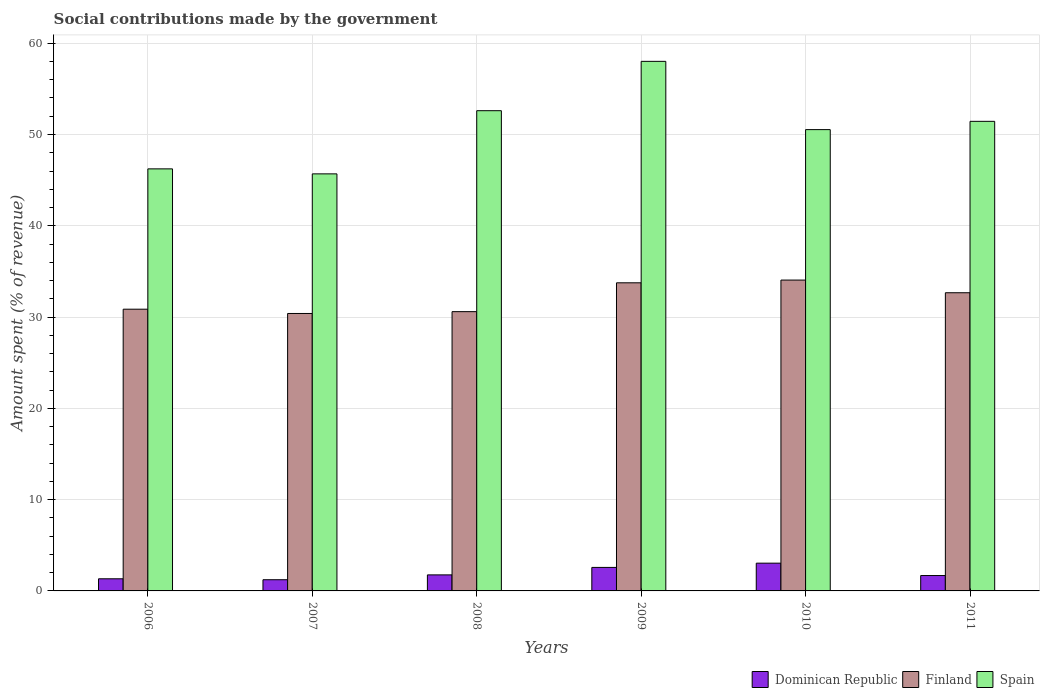Are the number of bars per tick equal to the number of legend labels?
Your response must be concise. Yes. Are the number of bars on each tick of the X-axis equal?
Offer a very short reply. Yes. How many bars are there on the 6th tick from the left?
Ensure brevity in your answer.  3. How many bars are there on the 2nd tick from the right?
Offer a very short reply. 3. In how many cases, is the number of bars for a given year not equal to the number of legend labels?
Keep it short and to the point. 0. What is the amount spent (in %) on social contributions in Finland in 2007?
Your response must be concise. 30.39. Across all years, what is the maximum amount spent (in %) on social contributions in Spain?
Your response must be concise. 58.01. Across all years, what is the minimum amount spent (in %) on social contributions in Finland?
Ensure brevity in your answer.  30.39. In which year was the amount spent (in %) on social contributions in Finland minimum?
Your answer should be compact. 2007. What is the total amount spent (in %) on social contributions in Finland in the graph?
Keep it short and to the point. 192.32. What is the difference between the amount spent (in %) on social contributions in Dominican Republic in 2006 and that in 2007?
Your answer should be compact. 0.1. What is the difference between the amount spent (in %) on social contributions in Finland in 2008 and the amount spent (in %) on social contributions in Spain in 2009?
Offer a terse response. -27.42. What is the average amount spent (in %) on social contributions in Finland per year?
Make the answer very short. 32.05. In the year 2008, what is the difference between the amount spent (in %) on social contributions in Spain and amount spent (in %) on social contributions in Finland?
Your response must be concise. 22.01. In how many years, is the amount spent (in %) on social contributions in Dominican Republic greater than 20 %?
Give a very brief answer. 0. What is the ratio of the amount spent (in %) on social contributions in Spain in 2007 to that in 2009?
Your response must be concise. 0.79. Is the amount spent (in %) on social contributions in Dominican Republic in 2006 less than that in 2009?
Make the answer very short. Yes. Is the difference between the amount spent (in %) on social contributions in Spain in 2006 and 2010 greater than the difference between the amount spent (in %) on social contributions in Finland in 2006 and 2010?
Offer a very short reply. No. What is the difference between the highest and the second highest amount spent (in %) on social contributions in Finland?
Offer a terse response. 0.3. What is the difference between the highest and the lowest amount spent (in %) on social contributions in Dominican Republic?
Keep it short and to the point. 1.81. In how many years, is the amount spent (in %) on social contributions in Finland greater than the average amount spent (in %) on social contributions in Finland taken over all years?
Your answer should be compact. 3. Is the sum of the amount spent (in %) on social contributions in Spain in 2010 and 2011 greater than the maximum amount spent (in %) on social contributions in Dominican Republic across all years?
Make the answer very short. Yes. What does the 1st bar from the left in 2006 represents?
Keep it short and to the point. Dominican Republic. What does the 3rd bar from the right in 2010 represents?
Give a very brief answer. Dominican Republic. Are all the bars in the graph horizontal?
Keep it short and to the point. No. How many years are there in the graph?
Provide a succinct answer. 6. What is the difference between two consecutive major ticks on the Y-axis?
Your answer should be very brief. 10. Does the graph contain grids?
Keep it short and to the point. Yes. Where does the legend appear in the graph?
Keep it short and to the point. Bottom right. How many legend labels are there?
Your response must be concise. 3. How are the legend labels stacked?
Your answer should be compact. Horizontal. What is the title of the graph?
Offer a very short reply. Social contributions made by the government. Does "Madagascar" appear as one of the legend labels in the graph?
Give a very brief answer. No. What is the label or title of the X-axis?
Ensure brevity in your answer.  Years. What is the label or title of the Y-axis?
Provide a succinct answer. Amount spent (% of revenue). What is the Amount spent (% of revenue) in Dominican Republic in 2006?
Provide a succinct answer. 1.33. What is the Amount spent (% of revenue) in Finland in 2006?
Make the answer very short. 30.86. What is the Amount spent (% of revenue) of Spain in 2006?
Offer a terse response. 46.23. What is the Amount spent (% of revenue) in Dominican Republic in 2007?
Your response must be concise. 1.23. What is the Amount spent (% of revenue) of Finland in 2007?
Keep it short and to the point. 30.39. What is the Amount spent (% of revenue) of Spain in 2007?
Your response must be concise. 45.69. What is the Amount spent (% of revenue) of Dominican Republic in 2008?
Keep it short and to the point. 1.76. What is the Amount spent (% of revenue) of Finland in 2008?
Give a very brief answer. 30.59. What is the Amount spent (% of revenue) of Spain in 2008?
Provide a short and direct response. 52.61. What is the Amount spent (% of revenue) in Dominican Republic in 2009?
Your answer should be compact. 2.58. What is the Amount spent (% of revenue) of Finland in 2009?
Your answer should be very brief. 33.75. What is the Amount spent (% of revenue) of Spain in 2009?
Offer a terse response. 58.01. What is the Amount spent (% of revenue) in Dominican Republic in 2010?
Your answer should be compact. 3.04. What is the Amount spent (% of revenue) in Finland in 2010?
Offer a very short reply. 34.05. What is the Amount spent (% of revenue) of Spain in 2010?
Offer a terse response. 50.53. What is the Amount spent (% of revenue) in Dominican Republic in 2011?
Ensure brevity in your answer.  1.68. What is the Amount spent (% of revenue) in Finland in 2011?
Ensure brevity in your answer.  32.67. What is the Amount spent (% of revenue) in Spain in 2011?
Provide a succinct answer. 51.44. Across all years, what is the maximum Amount spent (% of revenue) in Dominican Republic?
Offer a very short reply. 3.04. Across all years, what is the maximum Amount spent (% of revenue) of Finland?
Your response must be concise. 34.05. Across all years, what is the maximum Amount spent (% of revenue) in Spain?
Provide a succinct answer. 58.01. Across all years, what is the minimum Amount spent (% of revenue) in Dominican Republic?
Keep it short and to the point. 1.23. Across all years, what is the minimum Amount spent (% of revenue) of Finland?
Provide a short and direct response. 30.39. Across all years, what is the minimum Amount spent (% of revenue) of Spain?
Your answer should be very brief. 45.69. What is the total Amount spent (% of revenue) in Dominican Republic in the graph?
Offer a terse response. 11.61. What is the total Amount spent (% of revenue) of Finland in the graph?
Your answer should be compact. 192.32. What is the total Amount spent (% of revenue) in Spain in the graph?
Offer a terse response. 304.52. What is the difference between the Amount spent (% of revenue) of Dominican Republic in 2006 and that in 2007?
Your answer should be very brief. 0.1. What is the difference between the Amount spent (% of revenue) in Finland in 2006 and that in 2007?
Ensure brevity in your answer.  0.47. What is the difference between the Amount spent (% of revenue) in Spain in 2006 and that in 2007?
Provide a succinct answer. 0.55. What is the difference between the Amount spent (% of revenue) in Dominican Republic in 2006 and that in 2008?
Provide a succinct answer. -0.43. What is the difference between the Amount spent (% of revenue) in Finland in 2006 and that in 2008?
Make the answer very short. 0.27. What is the difference between the Amount spent (% of revenue) in Spain in 2006 and that in 2008?
Your answer should be very brief. -6.37. What is the difference between the Amount spent (% of revenue) of Dominican Republic in 2006 and that in 2009?
Your response must be concise. -1.25. What is the difference between the Amount spent (% of revenue) in Finland in 2006 and that in 2009?
Give a very brief answer. -2.89. What is the difference between the Amount spent (% of revenue) in Spain in 2006 and that in 2009?
Your answer should be compact. -11.78. What is the difference between the Amount spent (% of revenue) in Dominican Republic in 2006 and that in 2010?
Provide a succinct answer. -1.71. What is the difference between the Amount spent (% of revenue) in Finland in 2006 and that in 2010?
Ensure brevity in your answer.  -3.19. What is the difference between the Amount spent (% of revenue) in Spain in 2006 and that in 2010?
Make the answer very short. -4.3. What is the difference between the Amount spent (% of revenue) in Dominican Republic in 2006 and that in 2011?
Offer a terse response. -0.36. What is the difference between the Amount spent (% of revenue) of Finland in 2006 and that in 2011?
Your answer should be compact. -1.8. What is the difference between the Amount spent (% of revenue) in Spain in 2006 and that in 2011?
Offer a very short reply. -5.21. What is the difference between the Amount spent (% of revenue) of Dominican Republic in 2007 and that in 2008?
Offer a very short reply. -0.53. What is the difference between the Amount spent (% of revenue) in Finland in 2007 and that in 2008?
Ensure brevity in your answer.  -0.2. What is the difference between the Amount spent (% of revenue) in Spain in 2007 and that in 2008?
Offer a very short reply. -6.92. What is the difference between the Amount spent (% of revenue) of Dominican Republic in 2007 and that in 2009?
Keep it short and to the point. -1.35. What is the difference between the Amount spent (% of revenue) in Finland in 2007 and that in 2009?
Give a very brief answer. -3.36. What is the difference between the Amount spent (% of revenue) in Spain in 2007 and that in 2009?
Make the answer very short. -12.33. What is the difference between the Amount spent (% of revenue) of Dominican Republic in 2007 and that in 2010?
Your answer should be very brief. -1.81. What is the difference between the Amount spent (% of revenue) of Finland in 2007 and that in 2010?
Offer a very short reply. -3.66. What is the difference between the Amount spent (% of revenue) in Spain in 2007 and that in 2010?
Ensure brevity in your answer.  -4.85. What is the difference between the Amount spent (% of revenue) of Dominican Republic in 2007 and that in 2011?
Your answer should be compact. -0.46. What is the difference between the Amount spent (% of revenue) of Finland in 2007 and that in 2011?
Your answer should be very brief. -2.27. What is the difference between the Amount spent (% of revenue) of Spain in 2007 and that in 2011?
Make the answer very short. -5.75. What is the difference between the Amount spent (% of revenue) of Dominican Republic in 2008 and that in 2009?
Make the answer very short. -0.82. What is the difference between the Amount spent (% of revenue) in Finland in 2008 and that in 2009?
Provide a succinct answer. -3.16. What is the difference between the Amount spent (% of revenue) of Spain in 2008 and that in 2009?
Offer a terse response. -5.4. What is the difference between the Amount spent (% of revenue) of Dominican Republic in 2008 and that in 2010?
Provide a short and direct response. -1.28. What is the difference between the Amount spent (% of revenue) in Finland in 2008 and that in 2010?
Give a very brief answer. -3.46. What is the difference between the Amount spent (% of revenue) in Spain in 2008 and that in 2010?
Keep it short and to the point. 2.07. What is the difference between the Amount spent (% of revenue) of Dominican Republic in 2008 and that in 2011?
Keep it short and to the point. 0.07. What is the difference between the Amount spent (% of revenue) of Finland in 2008 and that in 2011?
Your answer should be very brief. -2.07. What is the difference between the Amount spent (% of revenue) of Spain in 2008 and that in 2011?
Keep it short and to the point. 1.17. What is the difference between the Amount spent (% of revenue) of Dominican Republic in 2009 and that in 2010?
Provide a succinct answer. -0.46. What is the difference between the Amount spent (% of revenue) in Finland in 2009 and that in 2010?
Provide a short and direct response. -0.3. What is the difference between the Amount spent (% of revenue) of Spain in 2009 and that in 2010?
Give a very brief answer. 7.48. What is the difference between the Amount spent (% of revenue) of Dominican Republic in 2009 and that in 2011?
Offer a terse response. 0.89. What is the difference between the Amount spent (% of revenue) of Finland in 2009 and that in 2011?
Provide a succinct answer. 1.09. What is the difference between the Amount spent (% of revenue) in Spain in 2009 and that in 2011?
Provide a succinct answer. 6.57. What is the difference between the Amount spent (% of revenue) of Dominican Republic in 2010 and that in 2011?
Provide a short and direct response. 1.36. What is the difference between the Amount spent (% of revenue) of Finland in 2010 and that in 2011?
Give a very brief answer. 1.39. What is the difference between the Amount spent (% of revenue) in Spain in 2010 and that in 2011?
Provide a succinct answer. -0.91. What is the difference between the Amount spent (% of revenue) of Dominican Republic in 2006 and the Amount spent (% of revenue) of Finland in 2007?
Give a very brief answer. -29.06. What is the difference between the Amount spent (% of revenue) of Dominican Republic in 2006 and the Amount spent (% of revenue) of Spain in 2007?
Your answer should be very brief. -44.36. What is the difference between the Amount spent (% of revenue) of Finland in 2006 and the Amount spent (% of revenue) of Spain in 2007?
Ensure brevity in your answer.  -14.83. What is the difference between the Amount spent (% of revenue) of Dominican Republic in 2006 and the Amount spent (% of revenue) of Finland in 2008?
Your answer should be compact. -29.26. What is the difference between the Amount spent (% of revenue) in Dominican Republic in 2006 and the Amount spent (% of revenue) in Spain in 2008?
Provide a short and direct response. -51.28. What is the difference between the Amount spent (% of revenue) in Finland in 2006 and the Amount spent (% of revenue) in Spain in 2008?
Keep it short and to the point. -21.75. What is the difference between the Amount spent (% of revenue) of Dominican Republic in 2006 and the Amount spent (% of revenue) of Finland in 2009?
Your answer should be very brief. -32.42. What is the difference between the Amount spent (% of revenue) of Dominican Republic in 2006 and the Amount spent (% of revenue) of Spain in 2009?
Give a very brief answer. -56.68. What is the difference between the Amount spent (% of revenue) in Finland in 2006 and the Amount spent (% of revenue) in Spain in 2009?
Your response must be concise. -27.15. What is the difference between the Amount spent (% of revenue) in Dominican Republic in 2006 and the Amount spent (% of revenue) in Finland in 2010?
Your answer should be compact. -32.72. What is the difference between the Amount spent (% of revenue) in Dominican Republic in 2006 and the Amount spent (% of revenue) in Spain in 2010?
Your answer should be very brief. -49.21. What is the difference between the Amount spent (% of revenue) of Finland in 2006 and the Amount spent (% of revenue) of Spain in 2010?
Keep it short and to the point. -19.67. What is the difference between the Amount spent (% of revenue) of Dominican Republic in 2006 and the Amount spent (% of revenue) of Finland in 2011?
Give a very brief answer. -31.34. What is the difference between the Amount spent (% of revenue) in Dominican Republic in 2006 and the Amount spent (% of revenue) in Spain in 2011?
Offer a very short reply. -50.11. What is the difference between the Amount spent (% of revenue) in Finland in 2006 and the Amount spent (% of revenue) in Spain in 2011?
Your answer should be compact. -20.58. What is the difference between the Amount spent (% of revenue) of Dominican Republic in 2007 and the Amount spent (% of revenue) of Finland in 2008?
Provide a short and direct response. -29.37. What is the difference between the Amount spent (% of revenue) of Dominican Republic in 2007 and the Amount spent (% of revenue) of Spain in 2008?
Your answer should be very brief. -51.38. What is the difference between the Amount spent (% of revenue) of Finland in 2007 and the Amount spent (% of revenue) of Spain in 2008?
Your answer should be compact. -22.21. What is the difference between the Amount spent (% of revenue) in Dominican Republic in 2007 and the Amount spent (% of revenue) in Finland in 2009?
Keep it short and to the point. -32.53. What is the difference between the Amount spent (% of revenue) in Dominican Republic in 2007 and the Amount spent (% of revenue) in Spain in 2009?
Make the answer very short. -56.79. What is the difference between the Amount spent (% of revenue) in Finland in 2007 and the Amount spent (% of revenue) in Spain in 2009?
Ensure brevity in your answer.  -27.62. What is the difference between the Amount spent (% of revenue) in Dominican Republic in 2007 and the Amount spent (% of revenue) in Finland in 2010?
Make the answer very short. -32.82. What is the difference between the Amount spent (% of revenue) in Dominican Republic in 2007 and the Amount spent (% of revenue) in Spain in 2010?
Offer a terse response. -49.31. What is the difference between the Amount spent (% of revenue) in Finland in 2007 and the Amount spent (% of revenue) in Spain in 2010?
Your answer should be very brief. -20.14. What is the difference between the Amount spent (% of revenue) of Dominican Republic in 2007 and the Amount spent (% of revenue) of Finland in 2011?
Your answer should be very brief. -31.44. What is the difference between the Amount spent (% of revenue) of Dominican Republic in 2007 and the Amount spent (% of revenue) of Spain in 2011?
Provide a succinct answer. -50.21. What is the difference between the Amount spent (% of revenue) in Finland in 2007 and the Amount spent (% of revenue) in Spain in 2011?
Your response must be concise. -21.05. What is the difference between the Amount spent (% of revenue) in Dominican Republic in 2008 and the Amount spent (% of revenue) in Finland in 2009?
Provide a succinct answer. -32. What is the difference between the Amount spent (% of revenue) of Dominican Republic in 2008 and the Amount spent (% of revenue) of Spain in 2009?
Offer a terse response. -56.25. What is the difference between the Amount spent (% of revenue) in Finland in 2008 and the Amount spent (% of revenue) in Spain in 2009?
Offer a terse response. -27.42. What is the difference between the Amount spent (% of revenue) of Dominican Republic in 2008 and the Amount spent (% of revenue) of Finland in 2010?
Your response must be concise. -32.29. What is the difference between the Amount spent (% of revenue) of Dominican Republic in 2008 and the Amount spent (% of revenue) of Spain in 2010?
Offer a very short reply. -48.78. What is the difference between the Amount spent (% of revenue) of Finland in 2008 and the Amount spent (% of revenue) of Spain in 2010?
Offer a very short reply. -19.94. What is the difference between the Amount spent (% of revenue) in Dominican Republic in 2008 and the Amount spent (% of revenue) in Finland in 2011?
Ensure brevity in your answer.  -30.91. What is the difference between the Amount spent (% of revenue) of Dominican Republic in 2008 and the Amount spent (% of revenue) of Spain in 2011?
Your answer should be very brief. -49.68. What is the difference between the Amount spent (% of revenue) of Finland in 2008 and the Amount spent (% of revenue) of Spain in 2011?
Your answer should be very brief. -20.85. What is the difference between the Amount spent (% of revenue) of Dominican Republic in 2009 and the Amount spent (% of revenue) of Finland in 2010?
Your answer should be compact. -31.48. What is the difference between the Amount spent (% of revenue) in Dominican Republic in 2009 and the Amount spent (% of revenue) in Spain in 2010?
Your answer should be very brief. -47.96. What is the difference between the Amount spent (% of revenue) in Finland in 2009 and the Amount spent (% of revenue) in Spain in 2010?
Your answer should be compact. -16.78. What is the difference between the Amount spent (% of revenue) in Dominican Republic in 2009 and the Amount spent (% of revenue) in Finland in 2011?
Your response must be concise. -30.09. What is the difference between the Amount spent (% of revenue) in Dominican Republic in 2009 and the Amount spent (% of revenue) in Spain in 2011?
Provide a succinct answer. -48.87. What is the difference between the Amount spent (% of revenue) in Finland in 2009 and the Amount spent (% of revenue) in Spain in 2011?
Your answer should be very brief. -17.69. What is the difference between the Amount spent (% of revenue) of Dominican Republic in 2010 and the Amount spent (% of revenue) of Finland in 2011?
Ensure brevity in your answer.  -29.63. What is the difference between the Amount spent (% of revenue) of Dominican Republic in 2010 and the Amount spent (% of revenue) of Spain in 2011?
Give a very brief answer. -48.4. What is the difference between the Amount spent (% of revenue) in Finland in 2010 and the Amount spent (% of revenue) in Spain in 2011?
Provide a short and direct response. -17.39. What is the average Amount spent (% of revenue) of Dominican Republic per year?
Ensure brevity in your answer.  1.94. What is the average Amount spent (% of revenue) in Finland per year?
Keep it short and to the point. 32.05. What is the average Amount spent (% of revenue) in Spain per year?
Provide a short and direct response. 50.75. In the year 2006, what is the difference between the Amount spent (% of revenue) in Dominican Republic and Amount spent (% of revenue) in Finland?
Keep it short and to the point. -29.53. In the year 2006, what is the difference between the Amount spent (% of revenue) in Dominican Republic and Amount spent (% of revenue) in Spain?
Offer a terse response. -44.91. In the year 2006, what is the difference between the Amount spent (% of revenue) of Finland and Amount spent (% of revenue) of Spain?
Provide a succinct answer. -15.37. In the year 2007, what is the difference between the Amount spent (% of revenue) in Dominican Republic and Amount spent (% of revenue) in Finland?
Give a very brief answer. -29.17. In the year 2007, what is the difference between the Amount spent (% of revenue) in Dominican Republic and Amount spent (% of revenue) in Spain?
Offer a terse response. -44.46. In the year 2007, what is the difference between the Amount spent (% of revenue) of Finland and Amount spent (% of revenue) of Spain?
Offer a terse response. -15.29. In the year 2008, what is the difference between the Amount spent (% of revenue) in Dominican Republic and Amount spent (% of revenue) in Finland?
Your response must be concise. -28.84. In the year 2008, what is the difference between the Amount spent (% of revenue) of Dominican Republic and Amount spent (% of revenue) of Spain?
Provide a succinct answer. -50.85. In the year 2008, what is the difference between the Amount spent (% of revenue) of Finland and Amount spent (% of revenue) of Spain?
Offer a terse response. -22.01. In the year 2009, what is the difference between the Amount spent (% of revenue) in Dominican Republic and Amount spent (% of revenue) in Finland?
Provide a succinct answer. -31.18. In the year 2009, what is the difference between the Amount spent (% of revenue) in Dominican Republic and Amount spent (% of revenue) in Spain?
Your answer should be very brief. -55.44. In the year 2009, what is the difference between the Amount spent (% of revenue) of Finland and Amount spent (% of revenue) of Spain?
Provide a succinct answer. -24.26. In the year 2010, what is the difference between the Amount spent (% of revenue) of Dominican Republic and Amount spent (% of revenue) of Finland?
Ensure brevity in your answer.  -31.01. In the year 2010, what is the difference between the Amount spent (% of revenue) in Dominican Republic and Amount spent (% of revenue) in Spain?
Offer a very short reply. -47.49. In the year 2010, what is the difference between the Amount spent (% of revenue) of Finland and Amount spent (% of revenue) of Spain?
Your answer should be very brief. -16.48. In the year 2011, what is the difference between the Amount spent (% of revenue) in Dominican Republic and Amount spent (% of revenue) in Finland?
Your response must be concise. -30.98. In the year 2011, what is the difference between the Amount spent (% of revenue) in Dominican Republic and Amount spent (% of revenue) in Spain?
Give a very brief answer. -49.76. In the year 2011, what is the difference between the Amount spent (% of revenue) in Finland and Amount spent (% of revenue) in Spain?
Provide a succinct answer. -18.78. What is the ratio of the Amount spent (% of revenue) of Dominican Republic in 2006 to that in 2007?
Ensure brevity in your answer.  1.08. What is the ratio of the Amount spent (% of revenue) of Finland in 2006 to that in 2007?
Make the answer very short. 1.02. What is the ratio of the Amount spent (% of revenue) in Dominican Republic in 2006 to that in 2008?
Offer a very short reply. 0.76. What is the ratio of the Amount spent (% of revenue) of Finland in 2006 to that in 2008?
Your answer should be compact. 1.01. What is the ratio of the Amount spent (% of revenue) in Spain in 2006 to that in 2008?
Make the answer very short. 0.88. What is the ratio of the Amount spent (% of revenue) of Dominican Republic in 2006 to that in 2009?
Your answer should be compact. 0.52. What is the ratio of the Amount spent (% of revenue) of Finland in 2006 to that in 2009?
Offer a very short reply. 0.91. What is the ratio of the Amount spent (% of revenue) in Spain in 2006 to that in 2009?
Your answer should be compact. 0.8. What is the ratio of the Amount spent (% of revenue) in Dominican Republic in 2006 to that in 2010?
Your answer should be very brief. 0.44. What is the ratio of the Amount spent (% of revenue) in Finland in 2006 to that in 2010?
Provide a succinct answer. 0.91. What is the ratio of the Amount spent (% of revenue) of Spain in 2006 to that in 2010?
Offer a terse response. 0.91. What is the ratio of the Amount spent (% of revenue) of Dominican Republic in 2006 to that in 2011?
Provide a short and direct response. 0.79. What is the ratio of the Amount spent (% of revenue) of Finland in 2006 to that in 2011?
Keep it short and to the point. 0.94. What is the ratio of the Amount spent (% of revenue) of Spain in 2006 to that in 2011?
Make the answer very short. 0.9. What is the ratio of the Amount spent (% of revenue) in Dominican Republic in 2007 to that in 2008?
Offer a terse response. 0.7. What is the ratio of the Amount spent (% of revenue) in Spain in 2007 to that in 2008?
Offer a very short reply. 0.87. What is the ratio of the Amount spent (% of revenue) of Dominican Republic in 2007 to that in 2009?
Your answer should be compact. 0.48. What is the ratio of the Amount spent (% of revenue) of Finland in 2007 to that in 2009?
Keep it short and to the point. 0.9. What is the ratio of the Amount spent (% of revenue) of Spain in 2007 to that in 2009?
Ensure brevity in your answer.  0.79. What is the ratio of the Amount spent (% of revenue) in Dominican Republic in 2007 to that in 2010?
Give a very brief answer. 0.4. What is the ratio of the Amount spent (% of revenue) of Finland in 2007 to that in 2010?
Offer a very short reply. 0.89. What is the ratio of the Amount spent (% of revenue) of Spain in 2007 to that in 2010?
Ensure brevity in your answer.  0.9. What is the ratio of the Amount spent (% of revenue) of Dominican Republic in 2007 to that in 2011?
Make the answer very short. 0.73. What is the ratio of the Amount spent (% of revenue) of Finland in 2007 to that in 2011?
Provide a short and direct response. 0.93. What is the ratio of the Amount spent (% of revenue) of Spain in 2007 to that in 2011?
Give a very brief answer. 0.89. What is the ratio of the Amount spent (% of revenue) in Dominican Republic in 2008 to that in 2009?
Give a very brief answer. 0.68. What is the ratio of the Amount spent (% of revenue) in Finland in 2008 to that in 2009?
Make the answer very short. 0.91. What is the ratio of the Amount spent (% of revenue) in Spain in 2008 to that in 2009?
Give a very brief answer. 0.91. What is the ratio of the Amount spent (% of revenue) of Dominican Republic in 2008 to that in 2010?
Your response must be concise. 0.58. What is the ratio of the Amount spent (% of revenue) of Finland in 2008 to that in 2010?
Your answer should be very brief. 0.9. What is the ratio of the Amount spent (% of revenue) of Spain in 2008 to that in 2010?
Make the answer very short. 1.04. What is the ratio of the Amount spent (% of revenue) in Dominican Republic in 2008 to that in 2011?
Your answer should be compact. 1.04. What is the ratio of the Amount spent (% of revenue) of Finland in 2008 to that in 2011?
Give a very brief answer. 0.94. What is the ratio of the Amount spent (% of revenue) in Spain in 2008 to that in 2011?
Offer a terse response. 1.02. What is the ratio of the Amount spent (% of revenue) in Dominican Republic in 2009 to that in 2010?
Provide a short and direct response. 0.85. What is the ratio of the Amount spent (% of revenue) of Finland in 2009 to that in 2010?
Offer a very short reply. 0.99. What is the ratio of the Amount spent (% of revenue) in Spain in 2009 to that in 2010?
Provide a short and direct response. 1.15. What is the ratio of the Amount spent (% of revenue) of Dominican Republic in 2009 to that in 2011?
Provide a succinct answer. 1.53. What is the ratio of the Amount spent (% of revenue) in Spain in 2009 to that in 2011?
Your response must be concise. 1.13. What is the ratio of the Amount spent (% of revenue) of Dominican Republic in 2010 to that in 2011?
Provide a short and direct response. 1.8. What is the ratio of the Amount spent (% of revenue) in Finland in 2010 to that in 2011?
Keep it short and to the point. 1.04. What is the ratio of the Amount spent (% of revenue) in Spain in 2010 to that in 2011?
Provide a short and direct response. 0.98. What is the difference between the highest and the second highest Amount spent (% of revenue) of Dominican Republic?
Give a very brief answer. 0.46. What is the difference between the highest and the second highest Amount spent (% of revenue) in Finland?
Give a very brief answer. 0.3. What is the difference between the highest and the second highest Amount spent (% of revenue) in Spain?
Your response must be concise. 5.4. What is the difference between the highest and the lowest Amount spent (% of revenue) of Dominican Republic?
Ensure brevity in your answer.  1.81. What is the difference between the highest and the lowest Amount spent (% of revenue) of Finland?
Keep it short and to the point. 3.66. What is the difference between the highest and the lowest Amount spent (% of revenue) of Spain?
Ensure brevity in your answer.  12.33. 